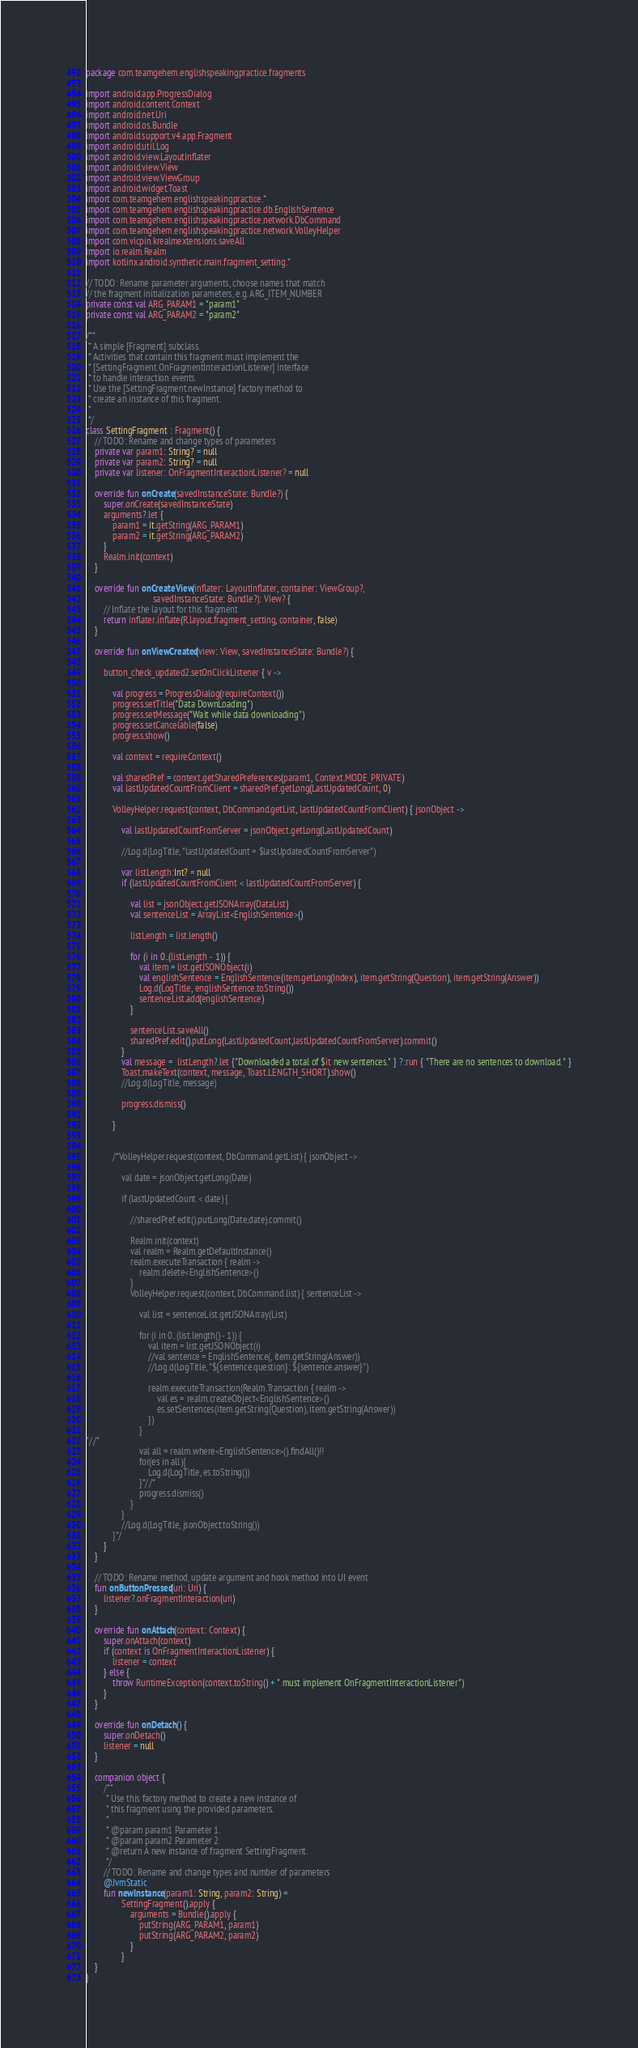Convert code to text. <code><loc_0><loc_0><loc_500><loc_500><_Kotlin_>package com.teamgehem.englishspeakingpractice.fragments

import android.app.ProgressDialog
import android.content.Context
import android.net.Uri
import android.os.Bundle
import android.support.v4.app.Fragment
import android.util.Log
import android.view.LayoutInflater
import android.view.View
import android.view.ViewGroup
import android.widget.Toast
import com.teamgehem.englishspeakingpractice.*
import com.teamgehem.englishspeakingpractice.db.EnglishSentence
import com.teamgehem.englishspeakingpractice.network.DbCommand
import com.teamgehem.englishspeakingpractice.network.VolleyHelper
import com.vicpin.krealmextensions.saveAll
import io.realm.Realm
import kotlinx.android.synthetic.main.fragment_setting.*

// TODO: Rename parameter arguments, choose names that match
// the fragment initialization parameters, e.g. ARG_ITEM_NUMBER
private const val ARG_PARAM1 = "param1"
private const val ARG_PARAM2 = "param2"

/**
 * A simple [Fragment] subclass.
 * Activities that contain this fragment must implement the
 * [SettingFragment.OnFragmentInteractionListener] interface
 * to handle interaction events.
 * Use the [SettingFragment.newInstance] factory method to
 * create an instance of this fragment.
 *
 */
class SettingFragment : Fragment() {
    // TODO: Rename and change types of parameters
    private var param1: String? = null
    private var param2: String? = null
    private var listener: OnFragmentInteractionListener? = null

    override fun onCreate(savedInstanceState: Bundle?) {
        super.onCreate(savedInstanceState)
        arguments?.let {
            param1 = it.getString(ARG_PARAM1)
            param2 = it.getString(ARG_PARAM2)
        }
        Realm.init(context)
    }

    override fun onCreateView(inflater: LayoutInflater, container: ViewGroup?,
                              savedInstanceState: Bundle?): View? {
        // Inflate the layout for this fragment
        return inflater.inflate(R.layout.fragment_setting, container, false)
    }

    override fun onViewCreated(view: View, savedInstanceState: Bundle?) {

        button_check_updated2.setOnClickListener { v ->

            val progress = ProgressDialog(requireContext())
            progress.setTitle("Data DownLoading")
            progress.setMessage("Wait while data downloading")
            progress.setCancelable(false)
            progress.show()

            val context = requireContext()

            val sharedPref = context.getSharedPreferences(param1, Context.MODE_PRIVATE)
            val lastUpdatedCountFromClient = sharedPref.getLong(LastUpdatedCount, 0)

            VolleyHelper.request(context, DbCommand.getList, lastUpdatedCountFromClient) { jsonObject ->

                val lastUpdatedCountFromServer = jsonObject.getLong(LastUpdatedCount)

                //Log.d(LogTitle, "lastUpdatedCount = $lastUpdatedCountFromServer")

                var listLength:Int? = null
                if (lastUpdatedCountFromClient < lastUpdatedCountFromServer) {

                    val list = jsonObject.getJSONArray(DataList)
                    val sentenceList = ArrayList<EnglishSentence>()

                    listLength = list.length()

                    for (i in 0..(listLength - 1)) {
                        val item = list.getJSONObject(i)
                        val englishSentence = EnglishSentence(item.getLong(Index), item.getString(Question), item.getString(Answer))
                        Log.d(LogTitle, englishSentence.toString())
                        sentenceList.add(englishSentence)
                    }

                    sentenceList.saveAll()
                    sharedPref.edit().putLong(LastUpdatedCount,lastUpdatedCountFromServer).commit()
                }
                val message =  listLength?.let {"Downloaded a total of $it new sentences." } ?:run { "There are no sentences to download." }
                Toast.makeText(context, message, Toast.LENGTH_SHORT).show()
                //Log.d(LogTitle, message)

                progress.dismiss()

            }


            /*VolleyHelper.request(context, DbCommand.getList) { jsonObject ->

                val date = jsonObject.getLong(Date)

                if (lastUpdatedCount < date) {

                    //sharedPref.edit().putLong(Date,date).commit()

                    Realm.init(context)
                    val realm = Realm.getDefaultInstance()
                    realm.executeTransaction { realm ->
                        realm.delete<EnglishSentence>()
                    }
                    VolleyHelper.request(context, DbCommand.list) { sentenceList ->

                        val list = sentenceList.getJSONArray(List)

                        for (i in 0..(list.length() - 1)) {
                            val item = list.getJSONObject(i)
                            //val sentence = EnglishSentence(, item.getString(Answer))
                            //Log.d(LogTitle, "${sentence.question}: ${sentence.answer}")

                            realm.executeTransaction(Realm.Transaction { realm ->
                                val es = realm.createObject<EnglishSentence>()
                                es.setSentences(item.getString(Question), item.getString(Answer))
                            })
                        }
*//*
                        val all = realm.where<EnglishSentence>().findAll()!!
                        for(es in all){
                            Log.d(LogTitle, es.toString())
                        }*//*
                        progress.dismiss()
                    }
                }
                //Log.d(LogTitle, jsonObject.toString())
            }*/
        }
    }

    // TODO: Rename method, update argument and hook method into UI event
    fun onButtonPressed(uri: Uri) {
        listener?.onFragmentInteraction(uri)
    }

    override fun onAttach(context: Context) {
        super.onAttach(context)
        if (context is OnFragmentInteractionListener) {
            listener = context
        } else {
            throw RuntimeException(context.toString() + " must implement OnFragmentInteractionListener")
        }
    }

    override fun onDetach() {
        super.onDetach()
        listener = null
    }

    companion object {
        /**
         * Use this factory method to create a new instance of
         * this fragment using the provided parameters.
         *
         * @param param1 Parameter 1.
         * @param param2 Parameter 2.
         * @return A new instance of fragment SettingFragment.
         */
        // TODO: Rename and change types and number of parameters
        @JvmStatic
        fun newInstance(param1: String, param2: String) =
                SettingFragment().apply {
                    arguments = Bundle().apply {
                        putString(ARG_PARAM1, param1)
                        putString(ARG_PARAM2, param2)
                    }
                }
    }
}
</code> 